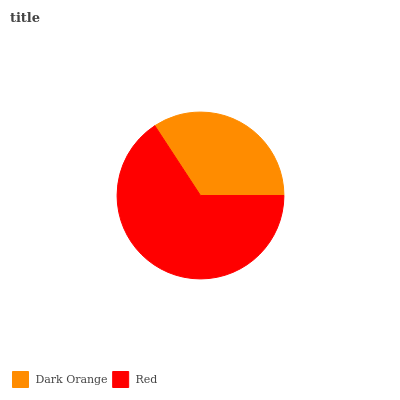Is Dark Orange the minimum?
Answer yes or no. Yes. Is Red the maximum?
Answer yes or no. Yes. Is Red the minimum?
Answer yes or no. No. Is Red greater than Dark Orange?
Answer yes or no. Yes. Is Dark Orange less than Red?
Answer yes or no. Yes. Is Dark Orange greater than Red?
Answer yes or no. No. Is Red less than Dark Orange?
Answer yes or no. No. Is Red the high median?
Answer yes or no. Yes. Is Dark Orange the low median?
Answer yes or no. Yes. Is Dark Orange the high median?
Answer yes or no. No. Is Red the low median?
Answer yes or no. No. 